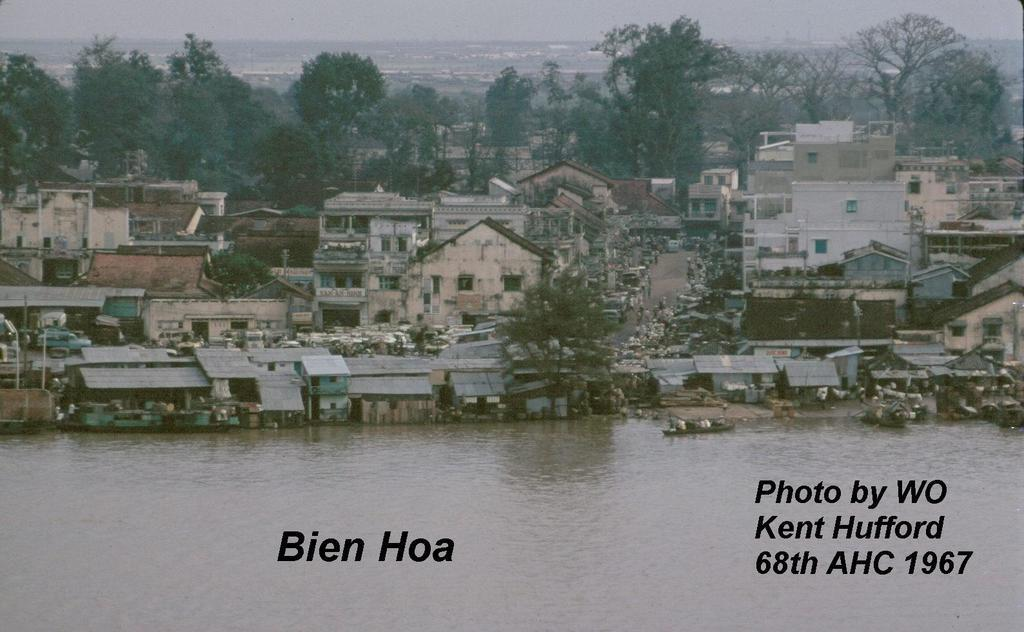What is the primary element visible in the image? There is water in the image. What type of natural vegetation can be seen in the image? There are trees in the image. What type of man-made structures are present in the image? There are houses in the image. What type of transportation is visible in the image? There are vehicles in the image. What is visible at the top of the image? The sky is visible at the top of the image. What type of sheet is being used to cover the water in the image? There is no sheet present in the image; the water is not covered. 